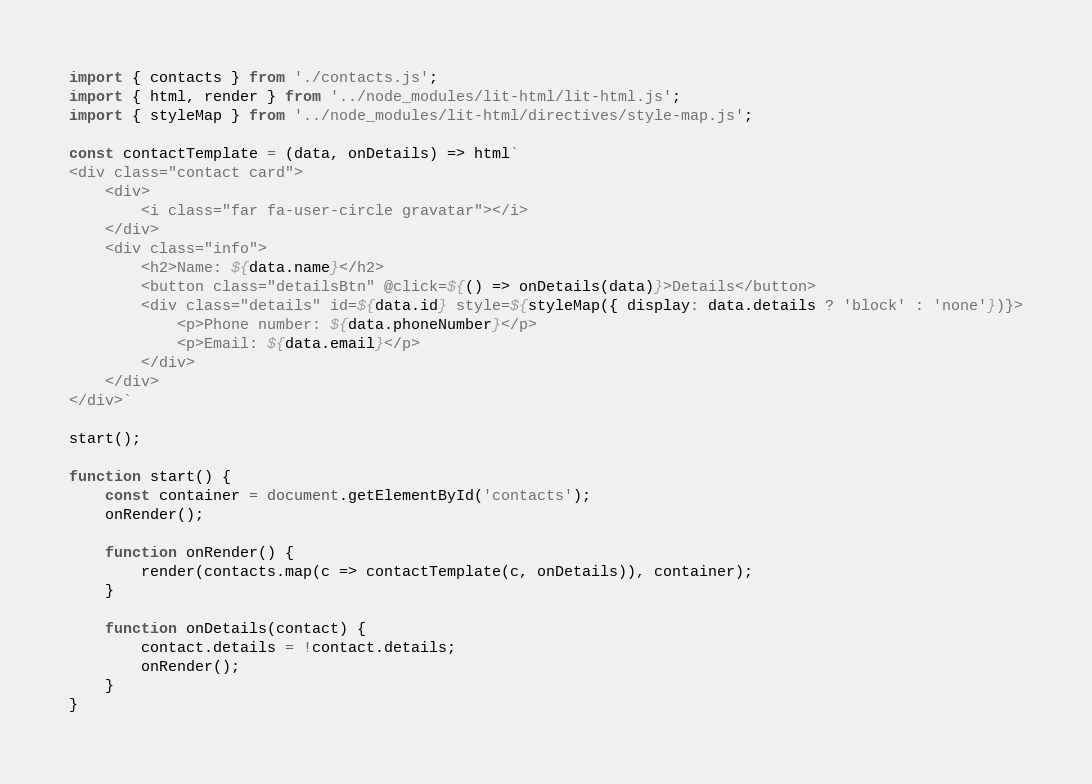<code> <loc_0><loc_0><loc_500><loc_500><_JavaScript_>import { contacts } from './contacts.js';
import { html, render } from '../node_modules/lit-html/lit-html.js';
import { styleMap } from '../node_modules/lit-html/directives/style-map.js';

const contactTemplate = (data, onDetails) => html`
<div class="contact card">
    <div>
        <i class="far fa-user-circle gravatar"></i>
    </div>
    <div class="info">
        <h2>Name: ${data.name}</h2>
        <button class="detailsBtn" @click=${() => onDetails(data)}>Details</button>
        <div class="details" id=${data.id} style=${styleMap({ display: data.details ? 'block' : 'none'})}>
            <p>Phone number: ${data.phoneNumber}</p>
            <p>Email: ${data.email}</p>
        </div>
    </div>
</div>`

start();

function start() {
    const container = document.getElementById('contacts');
    onRender();

    function onRender() {
        render(contacts.map(c => contactTemplate(c, onDetails)), container);
    }

    function onDetails(contact) {
        contact.details = !contact.details;
        onRender();
    }
}</code> 